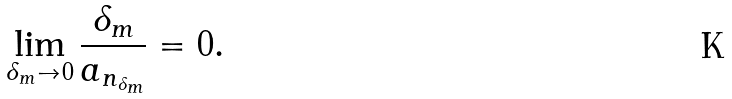Convert formula to latex. <formula><loc_0><loc_0><loc_500><loc_500>\lim _ { \delta _ { m } \to 0 } \frac { \delta _ { m } } { a _ { n _ { \delta _ { m } } } } = 0 .</formula> 